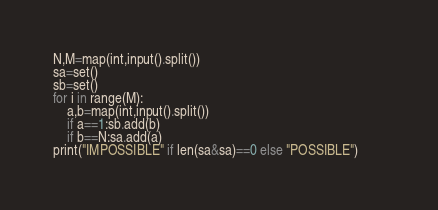<code> <loc_0><loc_0><loc_500><loc_500><_Python_>N,M=map(int,input().split())
sa=set()
sb=set()
for i in range(M):
    a,b=map(int,input().split())
    if a==1:sb.add(b)
    if b==N:sa.add(a)
print("IMPOSSIBLE" if len(sa&sa)==0 else "POSSIBLE")        </code> 